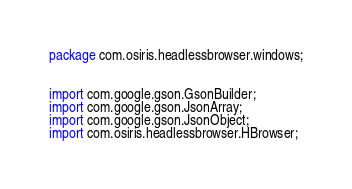Convert code to text. <code><loc_0><loc_0><loc_500><loc_500><_Java_>package com.osiris.headlessbrowser.windows;


import com.google.gson.GsonBuilder;
import com.google.gson.JsonArray;
import com.google.gson.JsonObject;
import com.osiris.headlessbrowser.HBrowser;</code> 